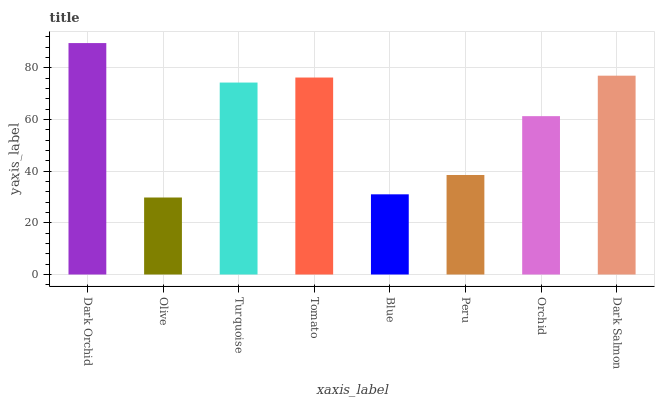Is Olive the minimum?
Answer yes or no. Yes. Is Dark Orchid the maximum?
Answer yes or no. Yes. Is Turquoise the minimum?
Answer yes or no. No. Is Turquoise the maximum?
Answer yes or no. No. Is Turquoise greater than Olive?
Answer yes or no. Yes. Is Olive less than Turquoise?
Answer yes or no. Yes. Is Olive greater than Turquoise?
Answer yes or no. No. Is Turquoise less than Olive?
Answer yes or no. No. Is Turquoise the high median?
Answer yes or no. Yes. Is Orchid the low median?
Answer yes or no. Yes. Is Blue the high median?
Answer yes or no. No. Is Blue the low median?
Answer yes or no. No. 